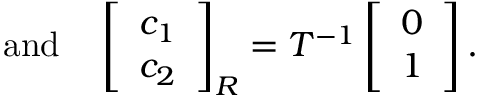<formula> <loc_0><loc_0><loc_500><loc_500>a n d \quad \left [ \begin{array} { l } { c _ { 1 } } \\ { c _ { 2 } } \end{array} \right ] _ { R } = T ^ { - 1 } \left [ \begin{array} { l } { 0 } \\ { 1 } \end{array} \right ] .</formula> 